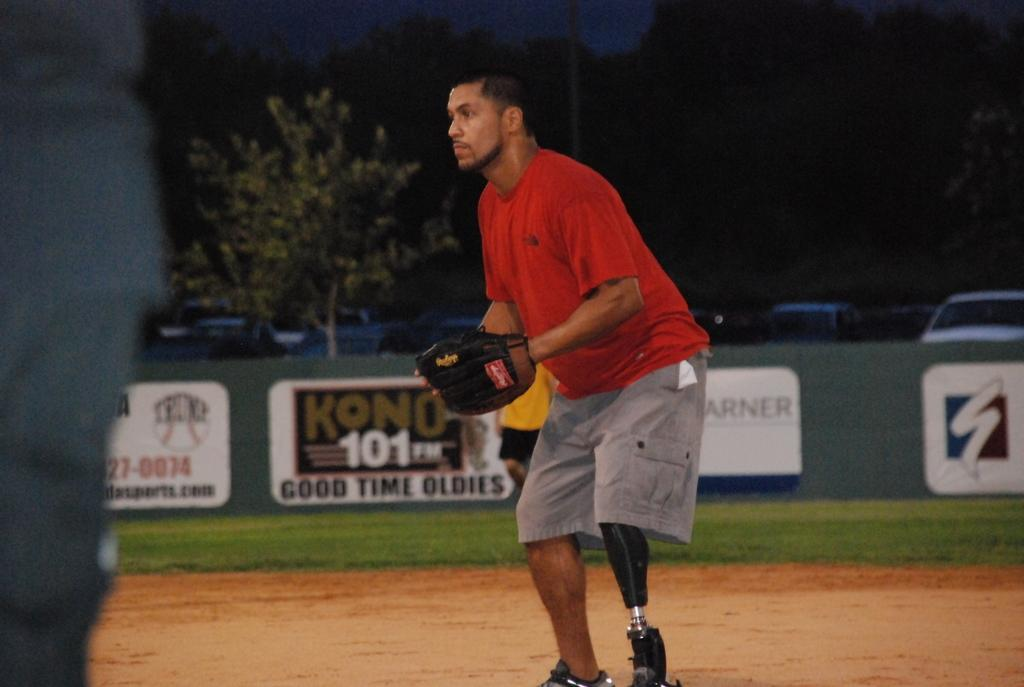What is the person in the image doing? The person is standing on the ground in the image. What is the person wearing on their hands? The person is wearing gloves. What can be seen in the background of the image? There are trees, poles, and vehicles in the background of the image. How would you describe the lighting in the background of the image? The background has a dark view. What type of bread is being exchanged between the goat and the person in the image? There is no bread or goat present in the image. How does the goat contribute to the exchange in the image? There is no goat or exchange present in the image. 